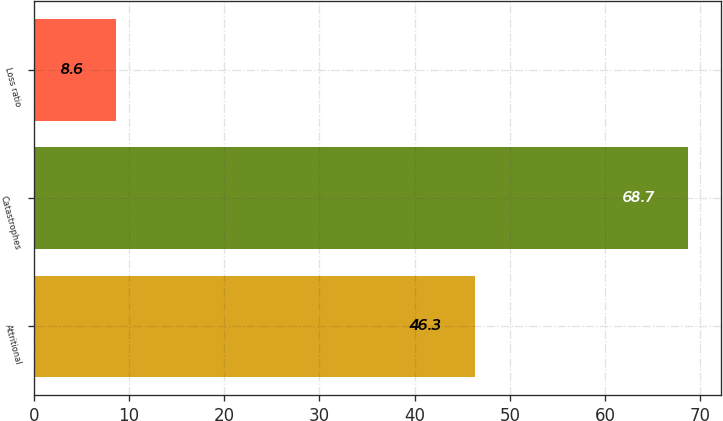Convert chart to OTSL. <chart><loc_0><loc_0><loc_500><loc_500><bar_chart><fcel>Attritional<fcel>Catastrophes<fcel>Loss ratio<nl><fcel>46.3<fcel>68.7<fcel>8.6<nl></chart> 